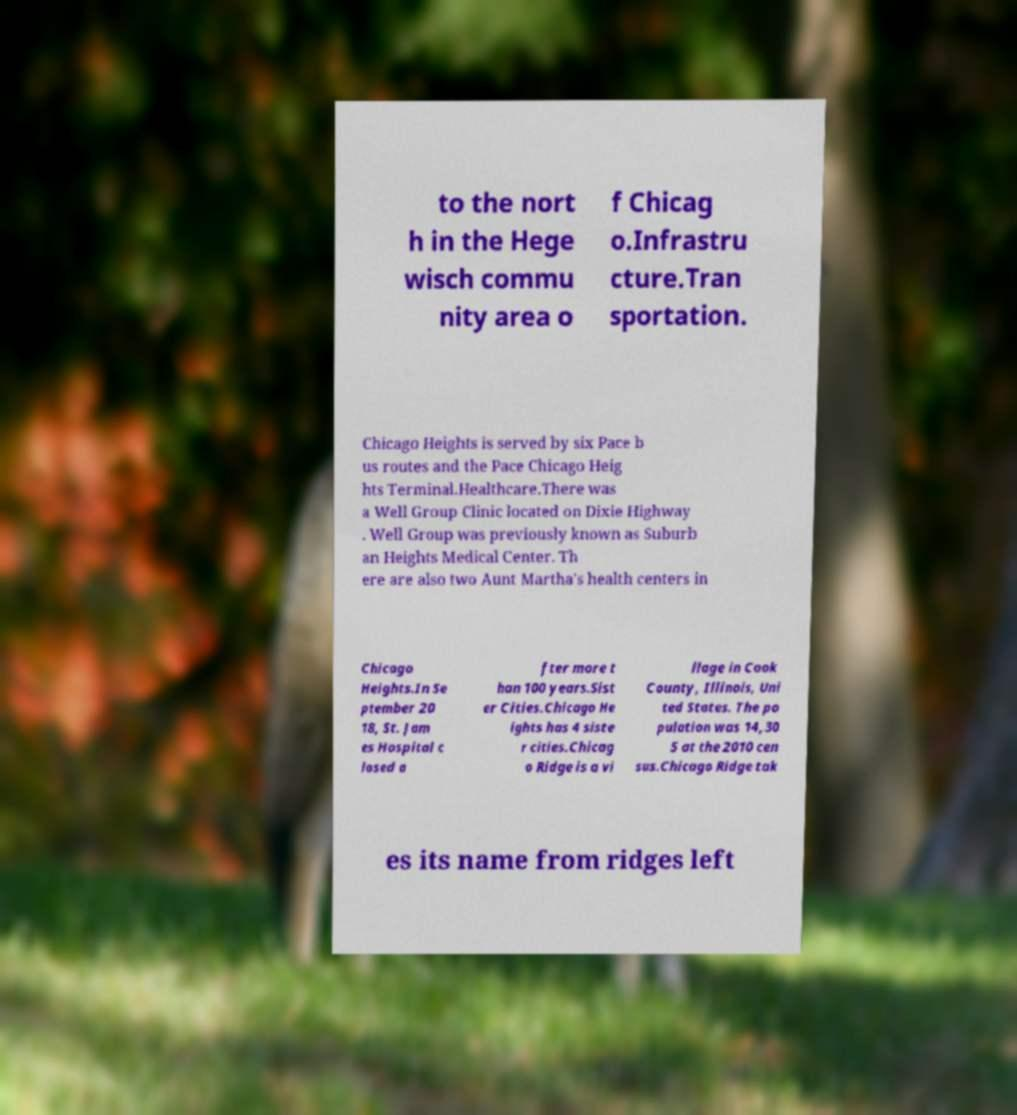What messages or text are displayed in this image? I need them in a readable, typed format. to the nort h in the Hege wisch commu nity area o f Chicag o.Infrastru cture.Tran sportation. Chicago Heights is served by six Pace b us routes and the Pace Chicago Heig hts Terminal.Healthcare.There was a Well Group Clinic located on Dixie Highway . Well Group was previously known as Suburb an Heights Medical Center. Th ere are also two Aunt Martha's health centers in Chicago Heights.In Se ptember 20 18, St. Jam es Hospital c losed a fter more t han 100 years.Sist er Cities.Chicago He ights has 4 siste r cities.Chicag o Ridge is a vi llage in Cook County, Illinois, Uni ted States. The po pulation was 14,30 5 at the 2010 cen sus.Chicago Ridge tak es its name from ridges left 